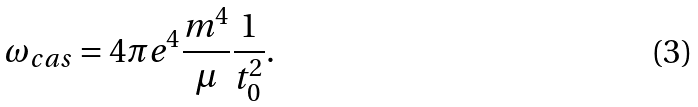Convert formula to latex. <formula><loc_0><loc_0><loc_500><loc_500>\omega _ { c a s } = 4 \pi e ^ { 4 } \frac { m ^ { 4 } } { \mu } \frac { 1 } { t _ { 0 } ^ { 2 } } .</formula> 